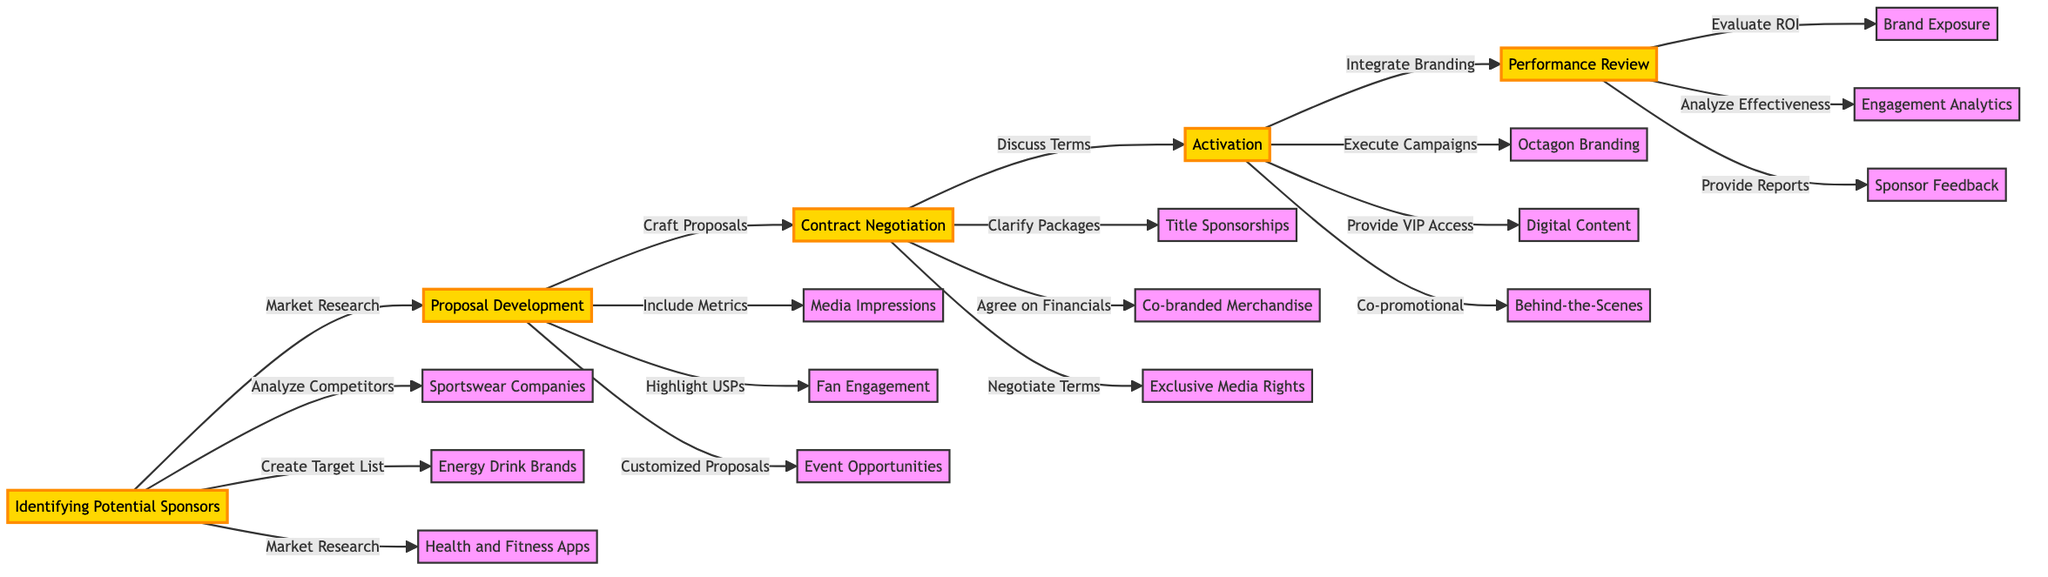What is the first step in the sponsorship acquisition strategy? The flowchart shows that the first step is "Identifying Potential Sponsors." This is clearly indicated as the starting node of the horizontal flowchart.
Answer: Identifying Potential Sponsors How many main steps are depicted in the diagram? The diagram contains five main steps: Identifying Potential Sponsors, Proposal Development, Contract Negotiation, Activation, and Performance Review. By counting these, we determine the number of main steps.
Answer: 5 What action is taken after Proposal Development? According to the flowchart, the action taken after Proposal Development is "Contract Negotiation," as it directly follows Proposal Development in the sequence.
Answer: Contract Negotiation Which companies are listed under Identifying Potential Sponsors? The flowchart specifies three types of companies under Identifying Potential Sponsors: Sportswear Companies, Energy Drink Brands, and Health and Fitness Apps. Reviewing the connections from that node reveals this information.
Answer: Sportswear Companies, Energy Drink Brands, Health and Fitness Apps What is one action taken during the Activation step? The diagram indicates several actions under the Activation step; one example is "Integrate Sponsor Branding at Events." This can be found as a direct action linked to the Activation node.
Answer: Integrate Sponsor Branding at Events How do you evaluate sponsor performance according to the diagram? The Performance Review step includes actions to evaluate sponsor performance such as "Evaluate Sponsor ROI" and "Analyze Campaign Effectiveness." Both of these actions require evaluating different aspects of the sponsorship. Hence, they dictate the evaluation process.
Answer: Evaluate Sponsor ROI What is the last action step in the flowchart? The final action in the flowchart occurs in the Performance Review step, which is "Provide Comprehensive Reports." This is the last link in the diagram and signifies the conclusion of the strategy.
Answer: Provide Comprehensive Reports How are sponsor agreements discussed in the diagram? The diagram indicates that during Contract Negotiation, the action "Discuss Terms and Conditions" is taken. This shows that discussions on agreements are part of the negotiation process directly linked to this node.
Answer: Discuss Terms and Conditions What type of sponsorship is mentioned under Contract Negotiation? The flowchart lists "Title Sponsorships" as one type of sponsorship mentioned under the Contract Negotiation step. This is shown as a real-world entity linked to that step.
Answer: Title Sponsorships 